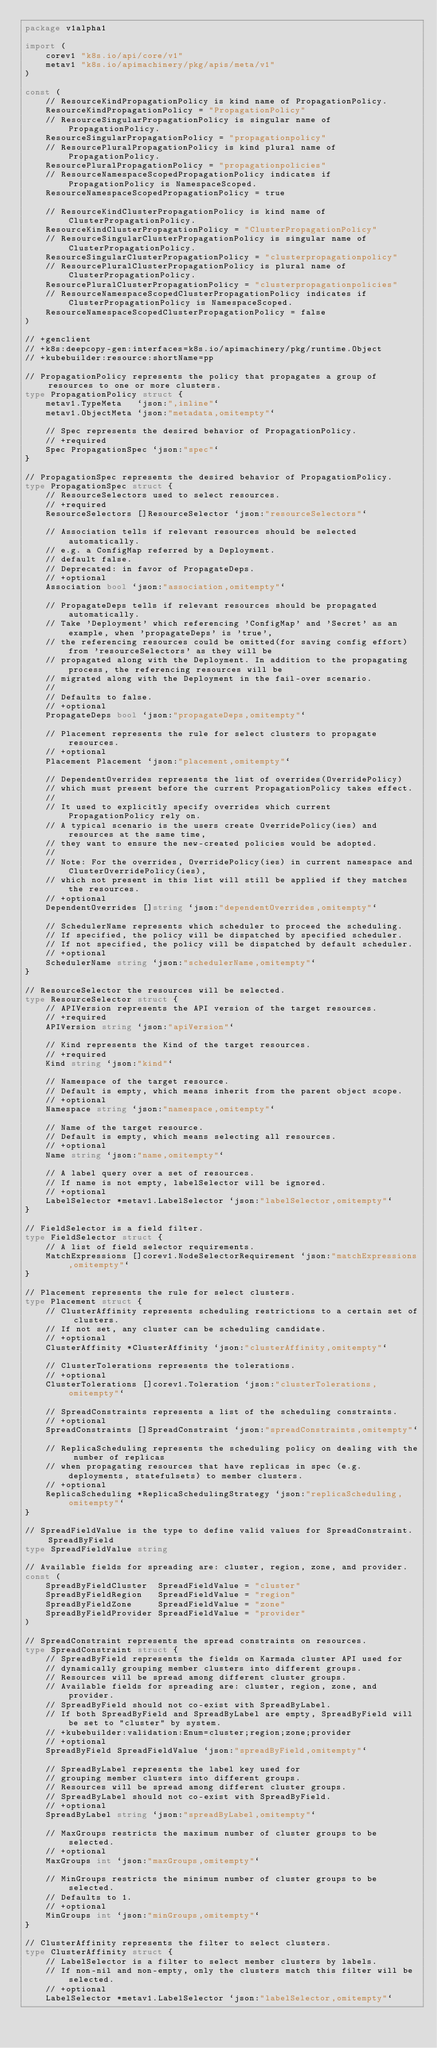Convert code to text. <code><loc_0><loc_0><loc_500><loc_500><_Go_>package v1alpha1

import (
	corev1 "k8s.io/api/core/v1"
	metav1 "k8s.io/apimachinery/pkg/apis/meta/v1"
)

const (
	// ResourceKindPropagationPolicy is kind name of PropagationPolicy.
	ResourceKindPropagationPolicy = "PropagationPolicy"
	// ResourceSingularPropagationPolicy is singular name of PropagationPolicy.
	ResourceSingularPropagationPolicy = "propagationpolicy"
	// ResourcePluralPropagationPolicy is kind plural name of PropagationPolicy.
	ResourcePluralPropagationPolicy = "propagationpolicies"
	// ResourceNamespaceScopedPropagationPolicy indicates if PropagationPolicy is NamespaceScoped.
	ResourceNamespaceScopedPropagationPolicy = true

	// ResourceKindClusterPropagationPolicy is kind name of ClusterPropagationPolicy.
	ResourceKindClusterPropagationPolicy = "ClusterPropagationPolicy"
	// ResourceSingularClusterPropagationPolicy is singular name of ClusterPropagationPolicy.
	ResourceSingularClusterPropagationPolicy = "clusterpropagationpolicy"
	// ResourcePluralClusterPropagationPolicy is plural name of ClusterPropagationPolicy.
	ResourcePluralClusterPropagationPolicy = "clusterpropagationpolicies"
	// ResourceNamespaceScopedClusterPropagationPolicy indicates if ClusterPropagationPolicy is NamespaceScoped.
	ResourceNamespaceScopedClusterPropagationPolicy = false
)

// +genclient
// +k8s:deepcopy-gen:interfaces=k8s.io/apimachinery/pkg/runtime.Object
// +kubebuilder:resource:shortName=pp

// PropagationPolicy represents the policy that propagates a group of resources to one or more clusters.
type PropagationPolicy struct {
	metav1.TypeMeta   `json:",inline"`
	metav1.ObjectMeta `json:"metadata,omitempty"`

	// Spec represents the desired behavior of PropagationPolicy.
	// +required
	Spec PropagationSpec `json:"spec"`
}

// PropagationSpec represents the desired behavior of PropagationPolicy.
type PropagationSpec struct {
	// ResourceSelectors used to select resources.
	// +required
	ResourceSelectors []ResourceSelector `json:"resourceSelectors"`

	// Association tells if relevant resources should be selected automatically.
	// e.g. a ConfigMap referred by a Deployment.
	// default false.
	// Deprecated: in favor of PropagateDeps.
	// +optional
	Association bool `json:"association,omitempty"`

	// PropagateDeps tells if relevant resources should be propagated automatically.
	// Take 'Deployment' which referencing 'ConfigMap' and 'Secret' as an example, when 'propagateDeps' is 'true',
	// the referencing resources could be omitted(for saving config effort) from 'resourceSelectors' as they will be
	// propagated along with the Deployment. In addition to the propagating process, the referencing resources will be
	// migrated along with the Deployment in the fail-over scenario.
	//
	// Defaults to false.
	// +optional
	PropagateDeps bool `json:"propagateDeps,omitempty"`

	// Placement represents the rule for select clusters to propagate resources.
	// +optional
	Placement Placement `json:"placement,omitempty"`

	// DependentOverrides represents the list of overrides(OverridePolicy)
	// which must present before the current PropagationPolicy takes effect.
	//
	// It used to explicitly specify overrides which current PropagationPolicy rely on.
	// A typical scenario is the users create OverridePolicy(ies) and resources at the same time,
	// they want to ensure the new-created policies would be adopted.
	//
	// Note: For the overrides, OverridePolicy(ies) in current namespace and ClusterOverridePolicy(ies),
	// which not present in this list will still be applied if they matches the resources.
	// +optional
	DependentOverrides []string `json:"dependentOverrides,omitempty"`

	// SchedulerName represents which scheduler to proceed the scheduling.
	// If specified, the policy will be dispatched by specified scheduler.
	// If not specified, the policy will be dispatched by default scheduler.
	// +optional
	SchedulerName string `json:"schedulerName,omitempty"`
}

// ResourceSelector the resources will be selected.
type ResourceSelector struct {
	// APIVersion represents the API version of the target resources.
	// +required
	APIVersion string `json:"apiVersion"`

	// Kind represents the Kind of the target resources.
	// +required
	Kind string `json:"kind"`

	// Namespace of the target resource.
	// Default is empty, which means inherit from the parent object scope.
	// +optional
	Namespace string `json:"namespace,omitempty"`

	// Name of the target resource.
	// Default is empty, which means selecting all resources.
	// +optional
	Name string `json:"name,omitempty"`

	// A label query over a set of resources.
	// If name is not empty, labelSelector will be ignored.
	// +optional
	LabelSelector *metav1.LabelSelector `json:"labelSelector,omitempty"`
}

// FieldSelector is a field filter.
type FieldSelector struct {
	// A list of field selector requirements.
	MatchExpressions []corev1.NodeSelectorRequirement `json:"matchExpressions,omitempty"`
}

// Placement represents the rule for select clusters.
type Placement struct {
	// ClusterAffinity represents scheduling restrictions to a certain set of clusters.
	// If not set, any cluster can be scheduling candidate.
	// +optional
	ClusterAffinity *ClusterAffinity `json:"clusterAffinity,omitempty"`

	// ClusterTolerations represents the tolerations.
	// +optional
	ClusterTolerations []corev1.Toleration `json:"clusterTolerations,omitempty"`

	// SpreadConstraints represents a list of the scheduling constraints.
	// +optional
	SpreadConstraints []SpreadConstraint `json:"spreadConstraints,omitempty"`

	// ReplicaScheduling represents the scheduling policy on dealing with the number of replicas
	// when propagating resources that have replicas in spec (e.g. deployments, statefulsets) to member clusters.
	// +optional
	ReplicaScheduling *ReplicaSchedulingStrategy `json:"replicaScheduling,omitempty"`
}

// SpreadFieldValue is the type to define valid values for SpreadConstraint.SpreadByField
type SpreadFieldValue string

// Available fields for spreading are: cluster, region, zone, and provider.
const (
	SpreadByFieldCluster  SpreadFieldValue = "cluster"
	SpreadByFieldRegion   SpreadFieldValue = "region"
	SpreadByFieldZone     SpreadFieldValue = "zone"
	SpreadByFieldProvider SpreadFieldValue = "provider"
)

// SpreadConstraint represents the spread constraints on resources.
type SpreadConstraint struct {
	// SpreadByField represents the fields on Karmada cluster API used for
	// dynamically grouping member clusters into different groups.
	// Resources will be spread among different cluster groups.
	// Available fields for spreading are: cluster, region, zone, and provider.
	// SpreadByField should not co-exist with SpreadByLabel.
	// If both SpreadByField and SpreadByLabel are empty, SpreadByField will be set to "cluster" by system.
	// +kubebuilder:validation:Enum=cluster;region;zone;provider
	// +optional
	SpreadByField SpreadFieldValue `json:"spreadByField,omitempty"`

	// SpreadByLabel represents the label key used for
	// grouping member clusters into different groups.
	// Resources will be spread among different cluster groups.
	// SpreadByLabel should not co-exist with SpreadByField.
	// +optional
	SpreadByLabel string `json:"spreadByLabel,omitempty"`

	// MaxGroups restricts the maximum number of cluster groups to be selected.
	// +optional
	MaxGroups int `json:"maxGroups,omitempty"`

	// MinGroups restricts the minimum number of cluster groups to be selected.
	// Defaults to 1.
	// +optional
	MinGroups int `json:"minGroups,omitempty"`
}

// ClusterAffinity represents the filter to select clusters.
type ClusterAffinity struct {
	// LabelSelector is a filter to select member clusters by labels.
	// If non-nil and non-empty, only the clusters match this filter will be selected.
	// +optional
	LabelSelector *metav1.LabelSelector `json:"labelSelector,omitempty"`
</code> 